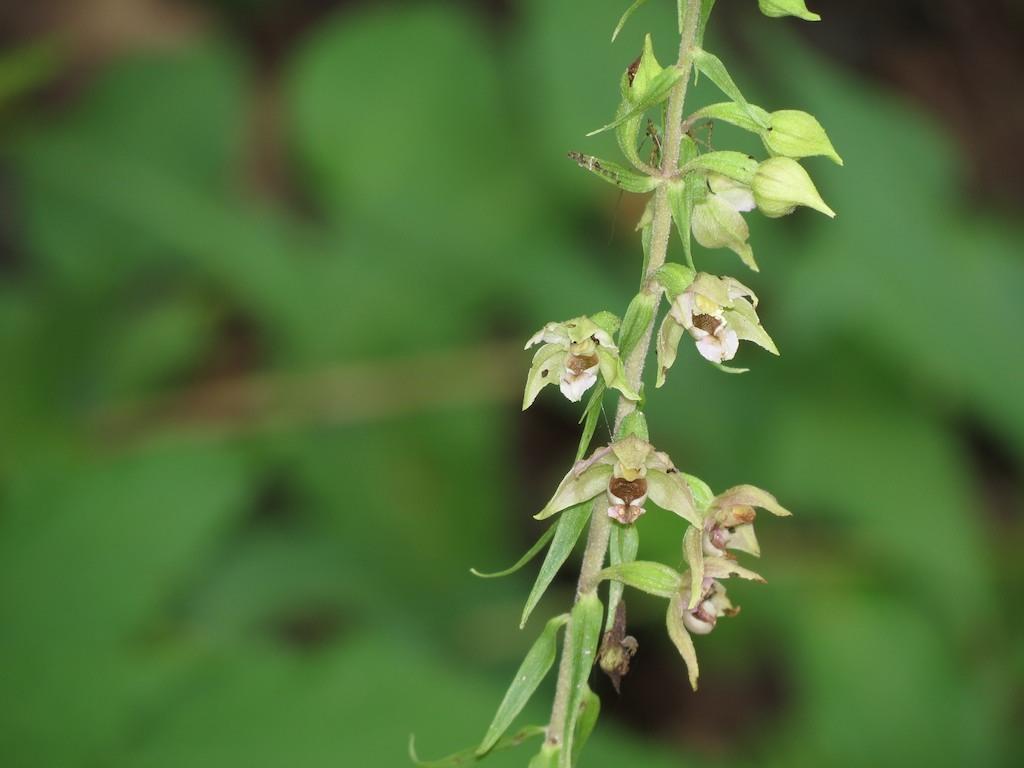Describe this image in one or two sentences. In the front of the image there is a plant and there are flowers. In the background of the image it is blurry.  